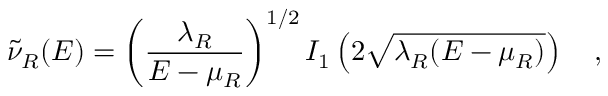Convert formula to latex. <formula><loc_0><loc_0><loc_500><loc_500>\tilde { \nu } _ { R } ( E ) = \left ( { \frac { \lambda _ { R } } { E - \mu _ { R } } } \right ) ^ { 1 / 2 } I _ { 1 } \left ( 2 \sqrt { \lambda _ { R } ( E - \mu _ { R } ) } \right ) ,</formula> 